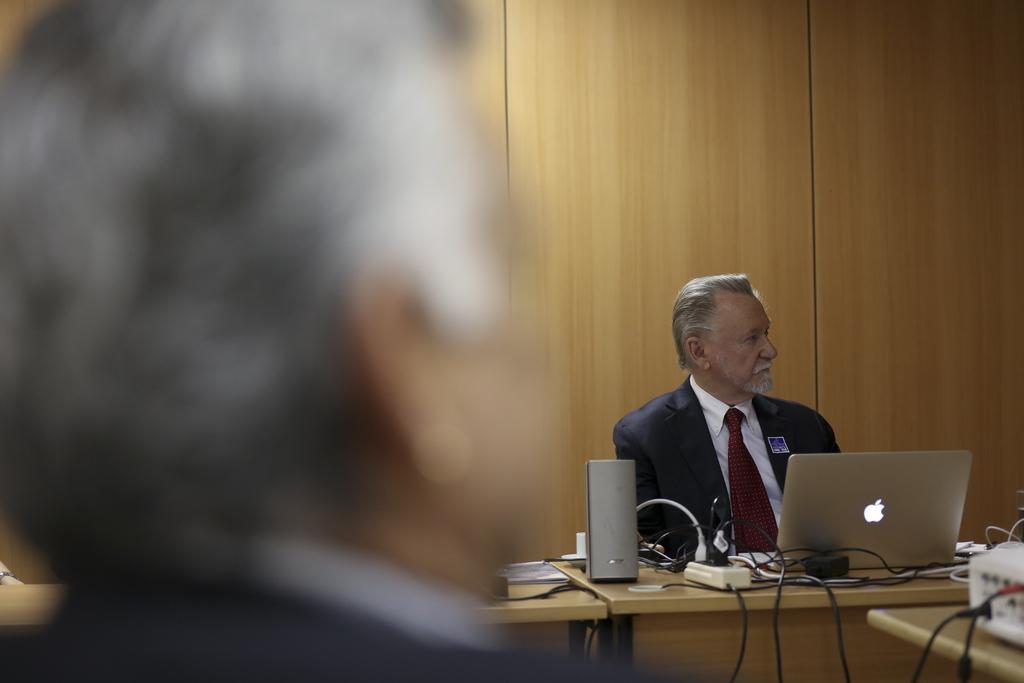In one or two sentences, can you explain what this image depicts? In this picture we can see a man who is sitting on the chair. This is table. On the table there is a laptop, cables, and a book. On the background there is a wall. 